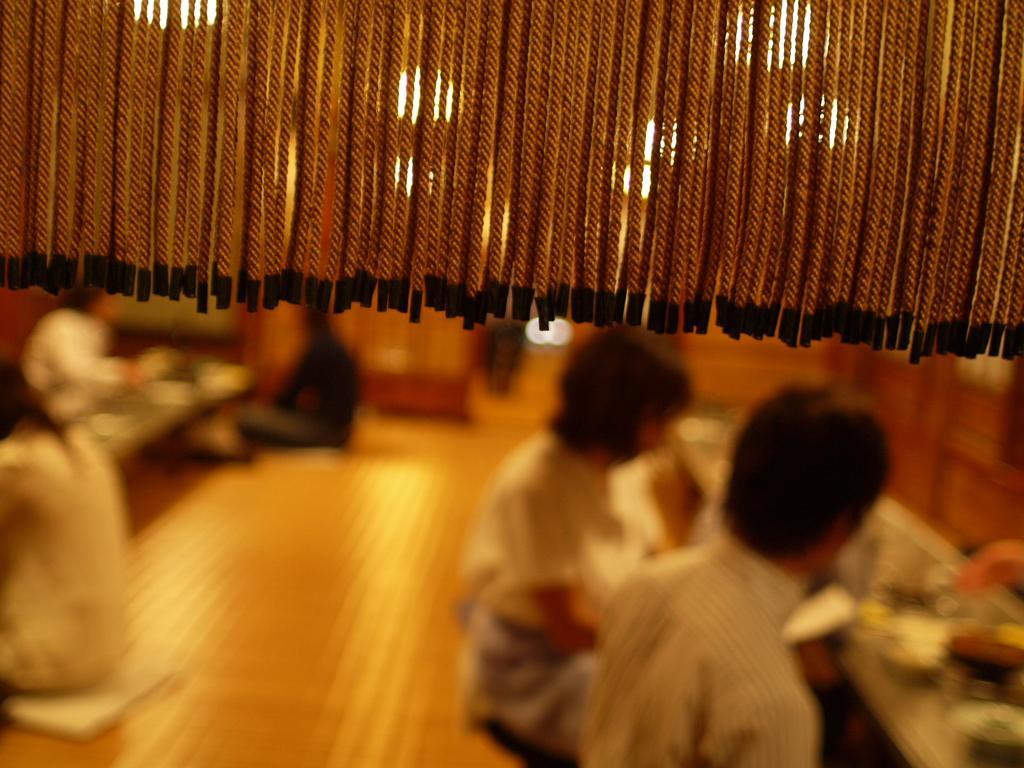Can you describe this image briefly? At the top of this image there are some threads hanging. At the bottom there are few people sitting on the floor. It seems like they are eating. In front of these people there are two tables on which I can see some objects. 